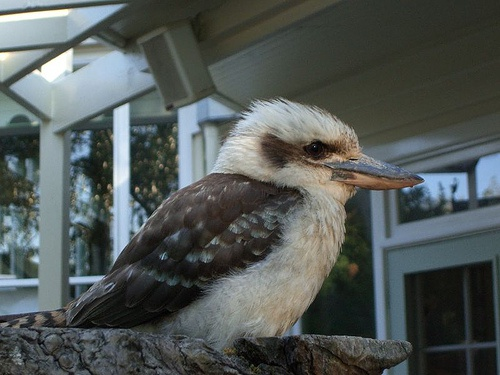Describe the objects in this image and their specific colors. I can see a bird in lightgray, black, darkgray, and gray tones in this image. 